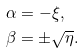<formula> <loc_0><loc_0><loc_500><loc_500>& \alpha = - \xi , \\ & \beta = \pm \sqrt { \eta } .</formula> 